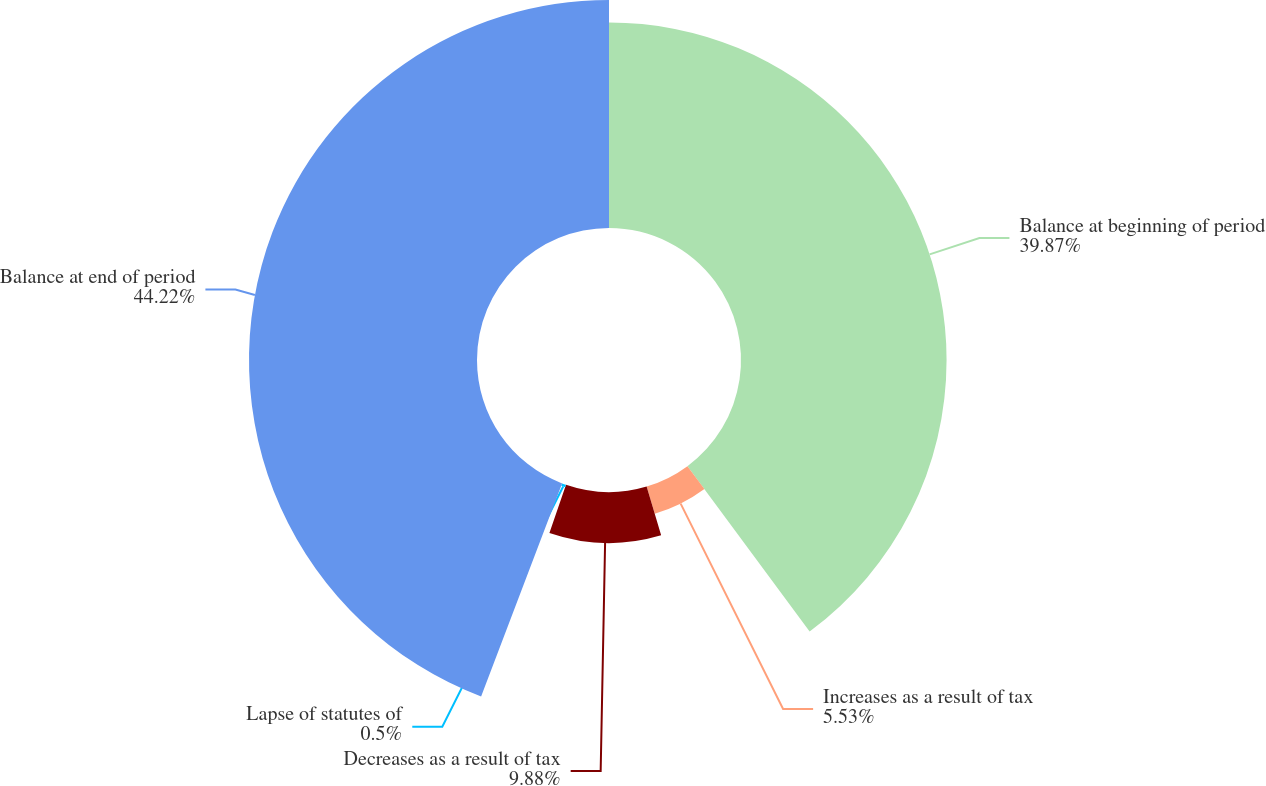<chart> <loc_0><loc_0><loc_500><loc_500><pie_chart><fcel>Balance at beginning of period<fcel>Increases as a result of tax<fcel>Decreases as a result of tax<fcel>Lapse of statutes of<fcel>Balance at end of period<nl><fcel>39.87%<fcel>5.53%<fcel>9.88%<fcel>0.5%<fcel>44.22%<nl></chart> 